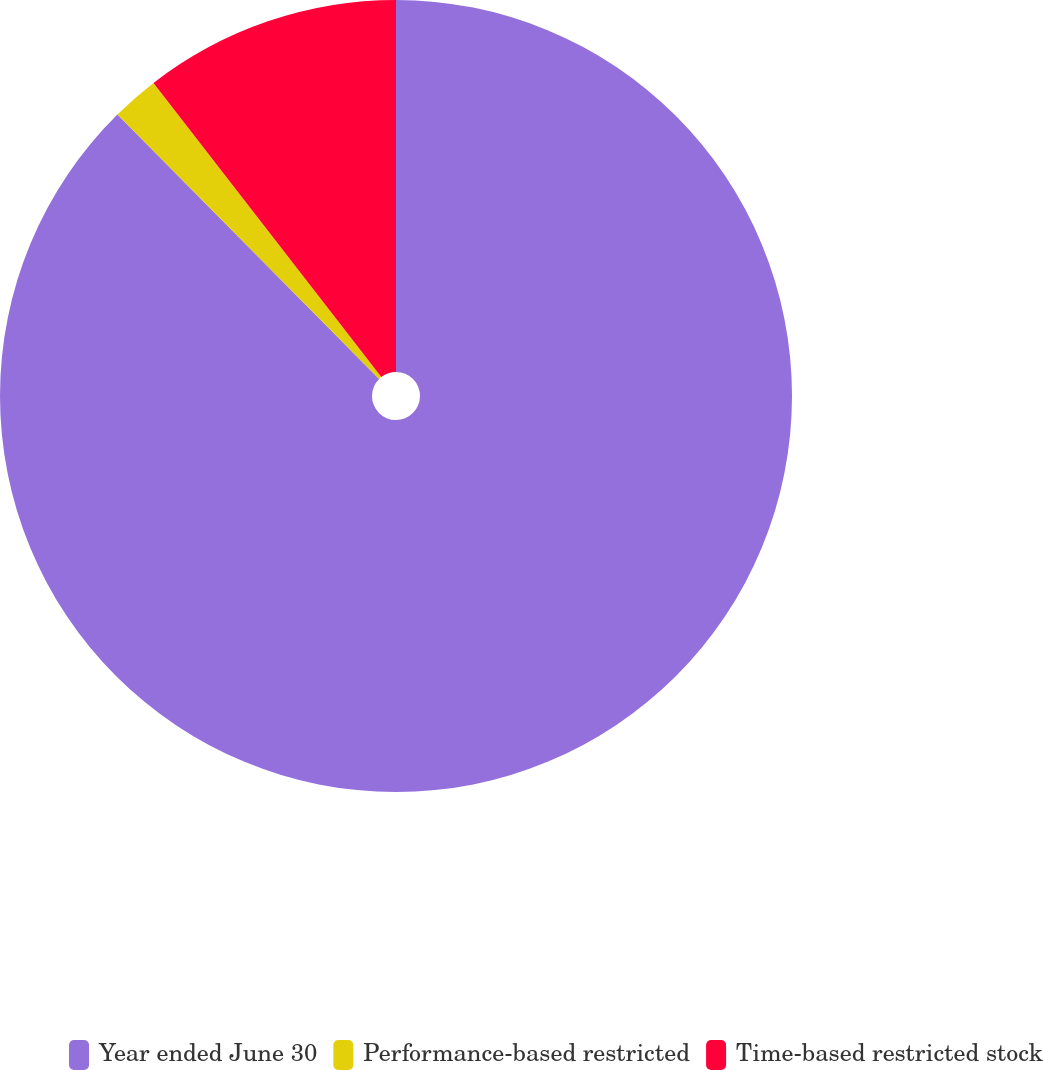Convert chart. <chart><loc_0><loc_0><loc_500><loc_500><pie_chart><fcel>Year ended June 30<fcel>Performance-based restricted<fcel>Time-based restricted stock<nl><fcel>87.58%<fcel>1.93%<fcel>10.49%<nl></chart> 